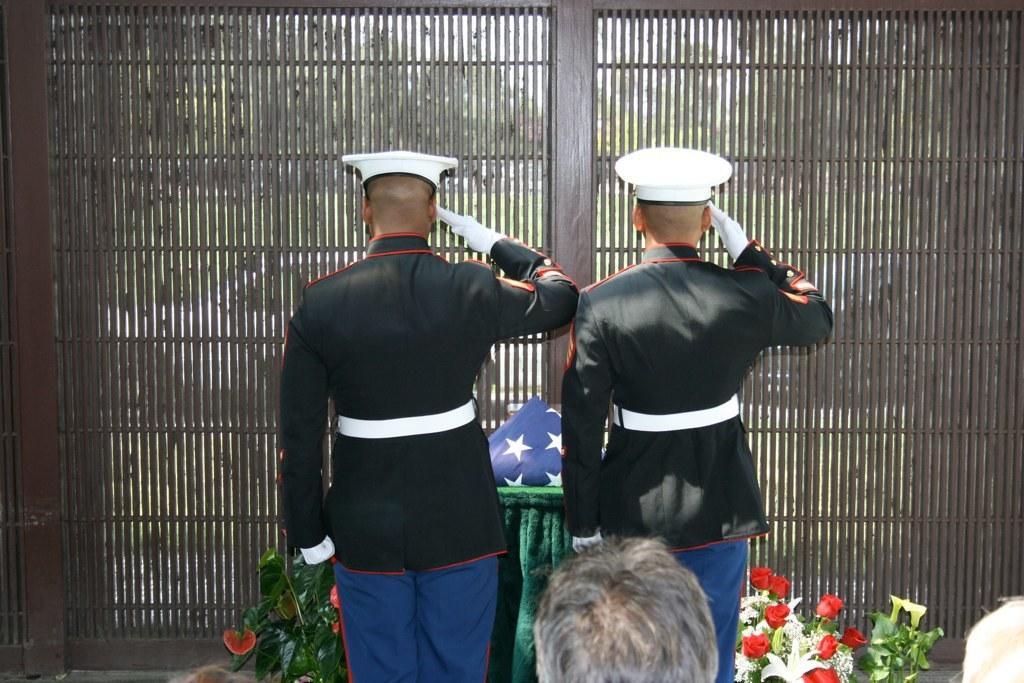Please provide a concise description of this image. In this image, we can see two persons standing and wearing clothes. There is a table in between flowers and leaves. This table contains a flag. There is a person head at the bottom of the image. In the background, we can see a grill wall. 